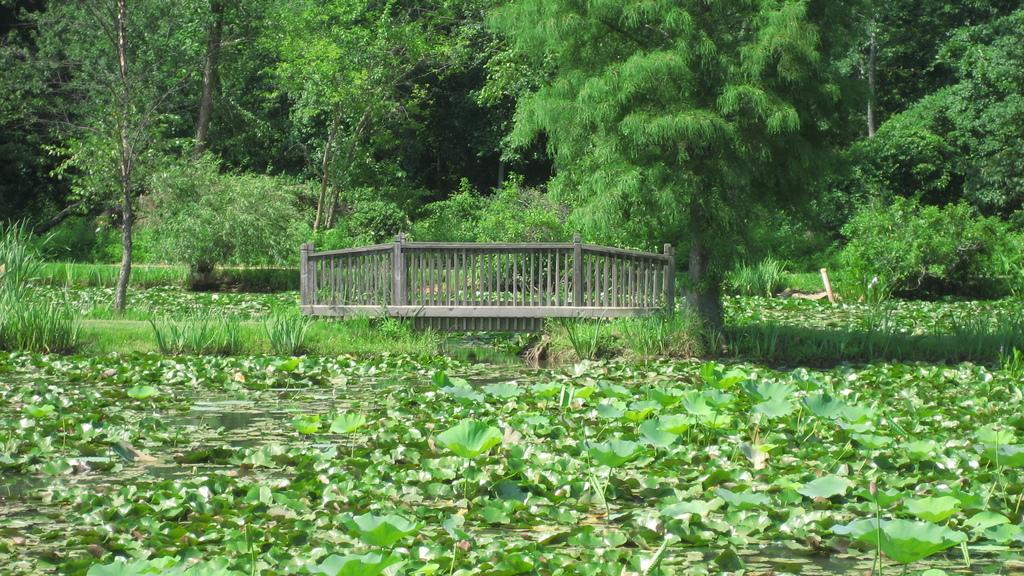What is located on the water in the foreground of the image? There are plants on the water in the foreground of the image. What structure can be seen in the foreground of the image? It appears to be a dock in the foreground. What type of vegetation is visible in the background of the image? There are trees in the background of the image. What time of day is the kitty playing with the hour in the image? There is no kitty or hour present in the image. What process is being depicted in the image? The image does not depict a specific process; it shows plants on the water, a dock, and trees in the background. 